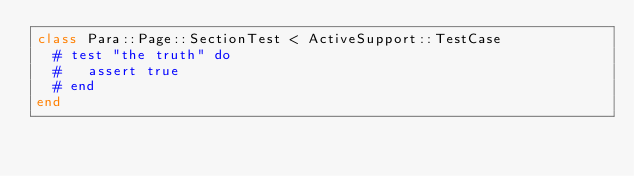<code> <loc_0><loc_0><loc_500><loc_500><_Ruby_>class Para::Page::SectionTest < ActiveSupport::TestCase
  # test "the truth" do
  #   assert true
  # end
end
</code> 